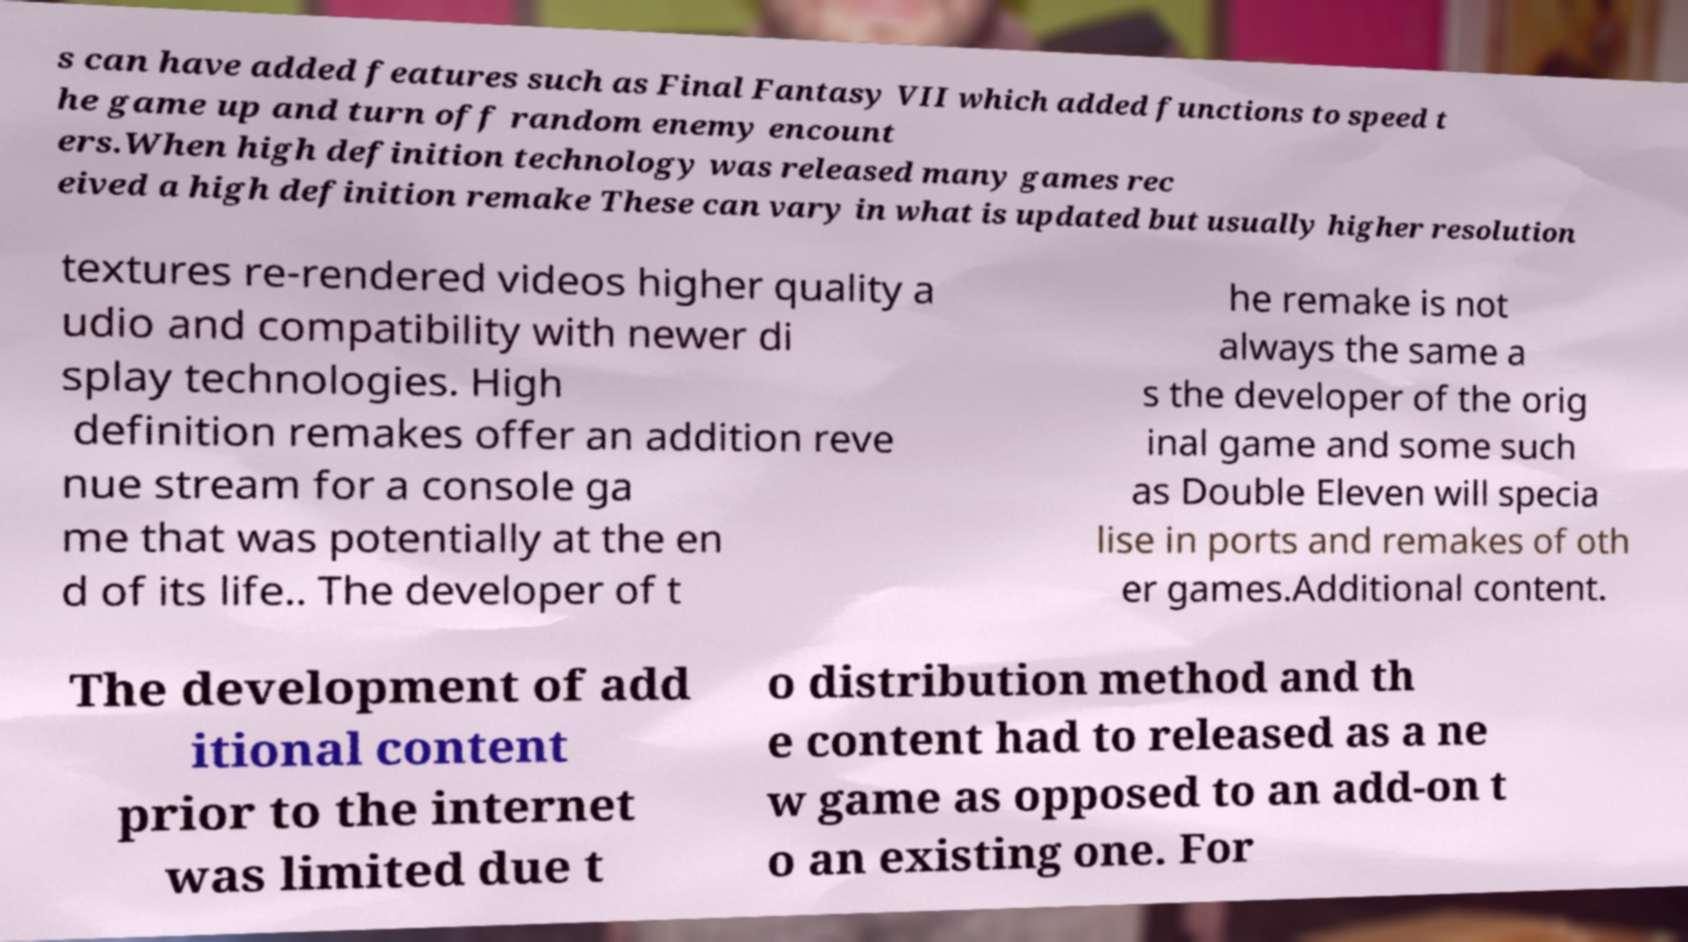For documentation purposes, I need the text within this image transcribed. Could you provide that? s can have added features such as Final Fantasy VII which added functions to speed t he game up and turn off random enemy encount ers.When high definition technology was released many games rec eived a high definition remake These can vary in what is updated but usually higher resolution textures re-rendered videos higher quality a udio and compatibility with newer di splay technologies. High definition remakes offer an addition reve nue stream for a console ga me that was potentially at the en d of its life.. The developer of t he remake is not always the same a s the developer of the orig inal game and some such as Double Eleven will specia lise in ports and remakes of oth er games.Additional content. The development of add itional content prior to the internet was limited due t o distribution method and th e content had to released as a ne w game as opposed to an add-on t o an existing one. For 